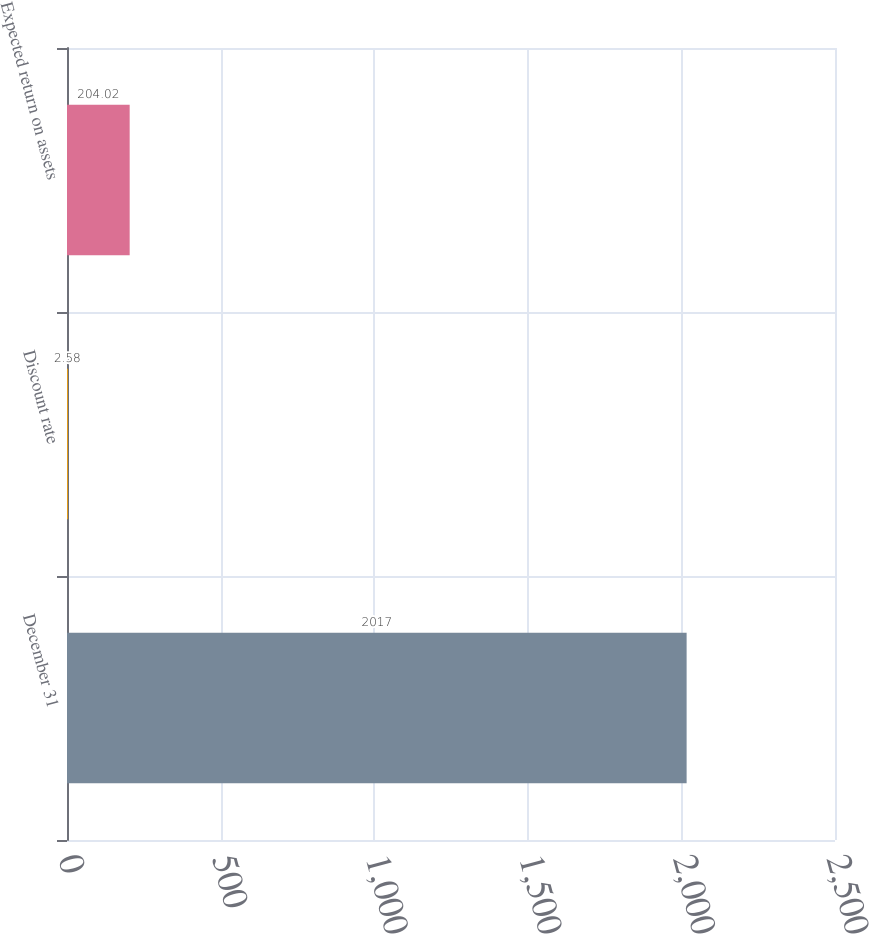Convert chart to OTSL. <chart><loc_0><loc_0><loc_500><loc_500><bar_chart><fcel>December 31<fcel>Discount rate<fcel>Expected return on assets<nl><fcel>2017<fcel>2.58<fcel>204.02<nl></chart> 